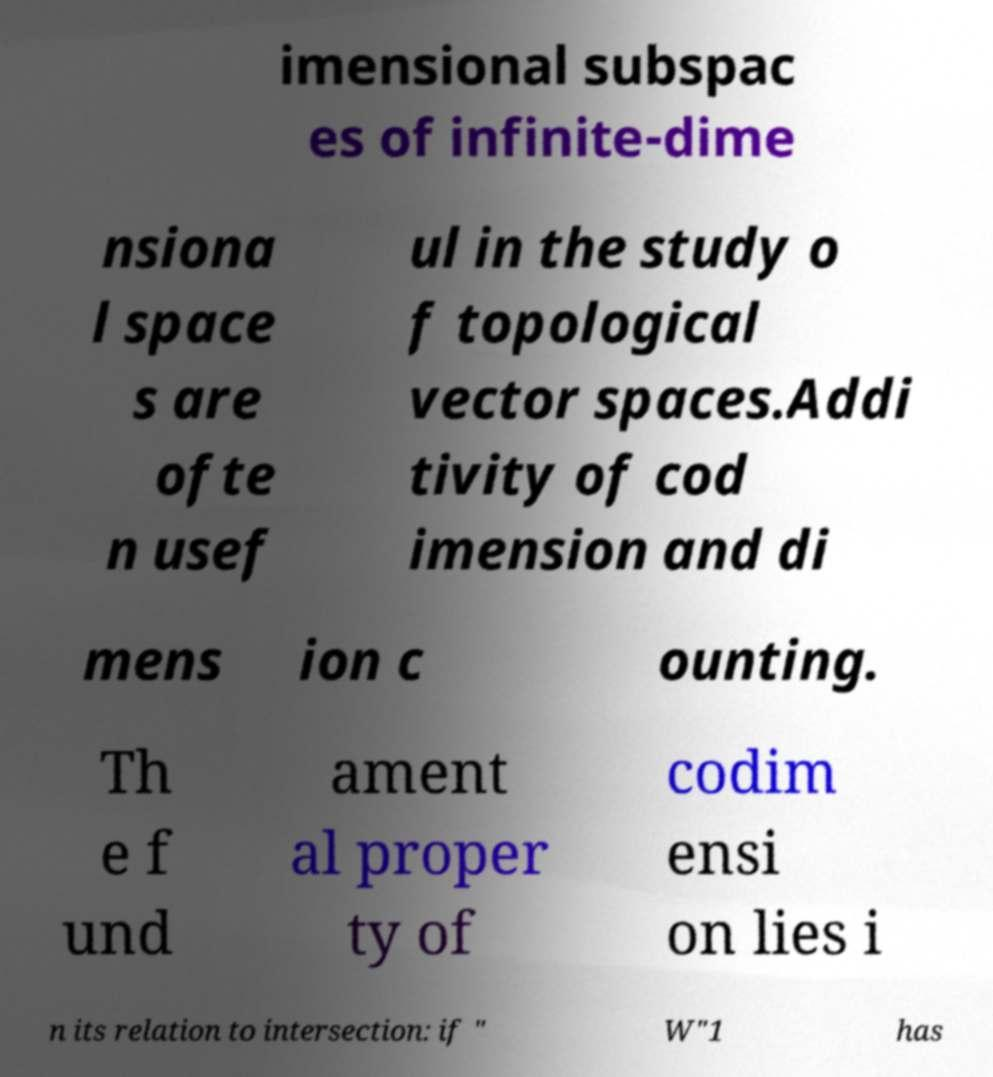Could you assist in decoding the text presented in this image and type it out clearly? imensional subspac es of infinite-dime nsiona l space s are ofte n usef ul in the study o f topological vector spaces.Addi tivity of cod imension and di mens ion c ounting. Th e f und ament al proper ty of codim ensi on lies i n its relation to intersection: if " W"1 has 